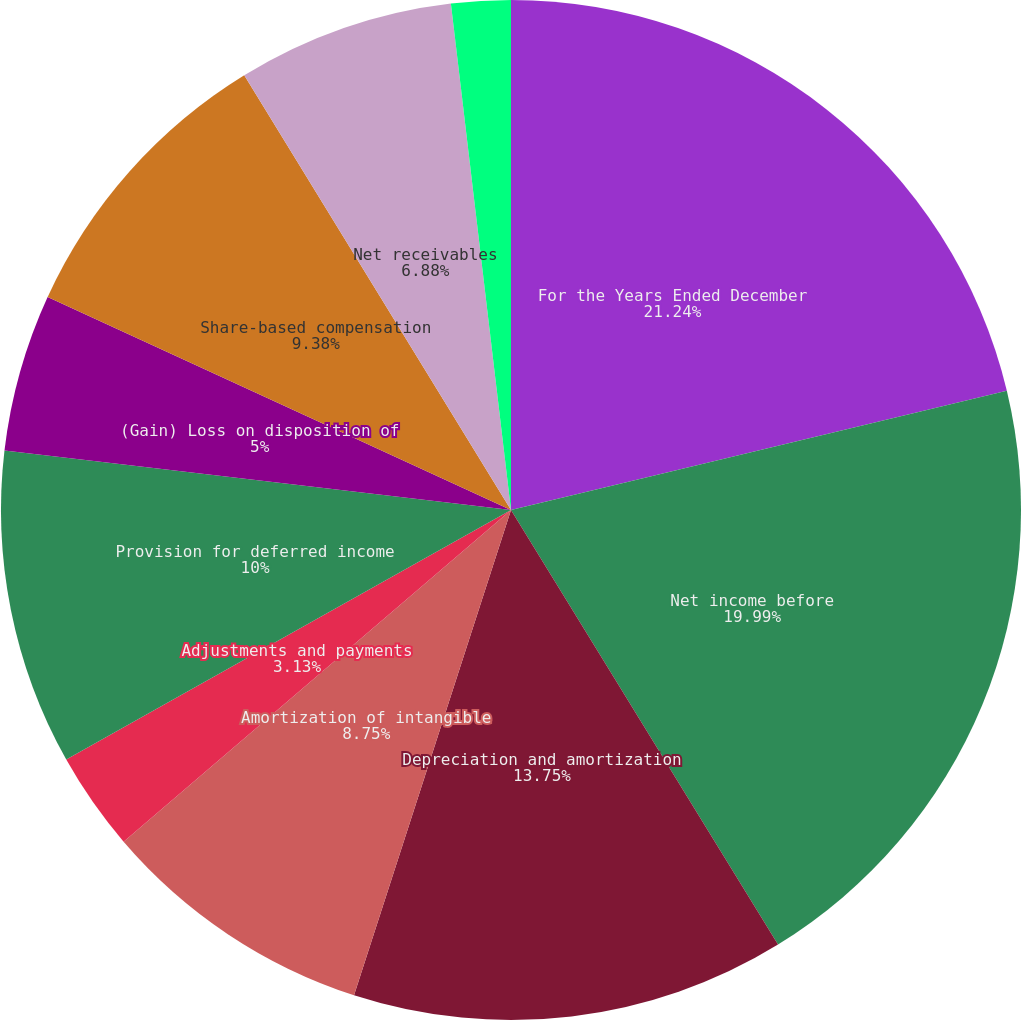Convert chart to OTSL. <chart><loc_0><loc_0><loc_500><loc_500><pie_chart><fcel>For the Years Ended December<fcel>Net income before<fcel>Depreciation and amortization<fcel>Amortization of intangible<fcel>Adjustments and payments<fcel>Provision for deferred income<fcel>(Gain) Loss on disposition of<fcel>Share-based compensation<fcel>Net receivables<fcel>Other current assets<nl><fcel>21.24%<fcel>19.99%<fcel>13.75%<fcel>8.75%<fcel>3.13%<fcel>10.0%<fcel>5.0%<fcel>9.38%<fcel>6.88%<fcel>1.88%<nl></chart> 